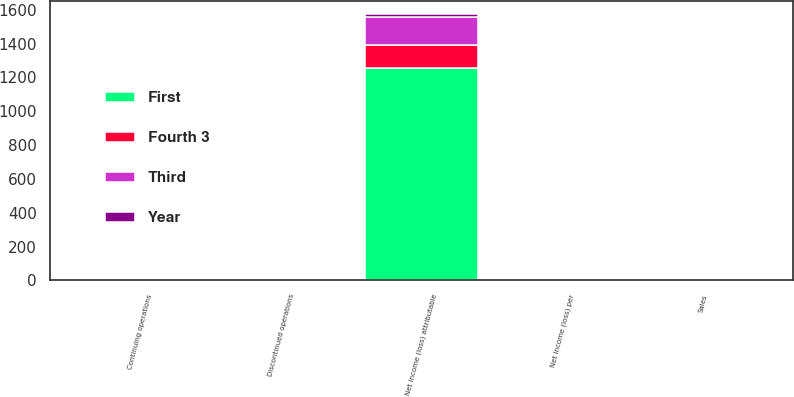Convert chart. <chart><loc_0><loc_0><loc_500><loc_500><stacked_bar_chart><ecel><fcel>Sales<fcel>Net income (loss) attributable<fcel>Continuing operations<fcel>Discontinued operations<fcel>Net income (loss) per<nl><fcel>Year<fcel>0.27<fcel>16<fcel>0.21<fcel>0.21<fcel>0<nl><fcel>Fourth 3<fcel>0.27<fcel>135<fcel>0.08<fcel>0.19<fcel>0.27<nl><fcel>Third<fcel>0.27<fcel>166<fcel>0.11<fcel>0.23<fcel>0.33<nl><fcel>First<fcel>0.27<fcel>1258<fcel>2.98<fcel>0.07<fcel>2.91<nl></chart> 